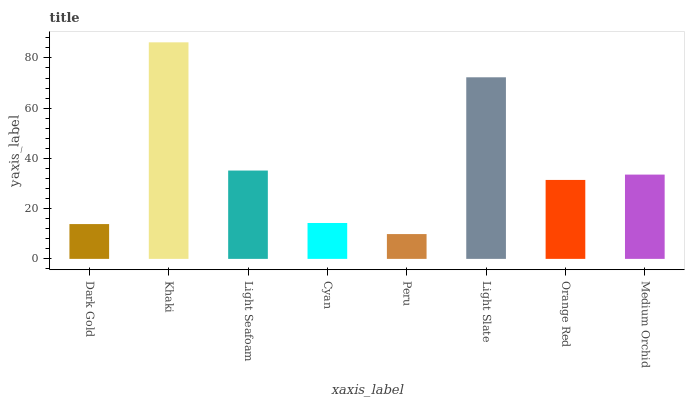Is Light Seafoam the minimum?
Answer yes or no. No. Is Light Seafoam the maximum?
Answer yes or no. No. Is Khaki greater than Light Seafoam?
Answer yes or no. Yes. Is Light Seafoam less than Khaki?
Answer yes or no. Yes. Is Light Seafoam greater than Khaki?
Answer yes or no. No. Is Khaki less than Light Seafoam?
Answer yes or no. No. Is Medium Orchid the high median?
Answer yes or no. Yes. Is Orange Red the low median?
Answer yes or no. Yes. Is Orange Red the high median?
Answer yes or no. No. Is Peru the low median?
Answer yes or no. No. 